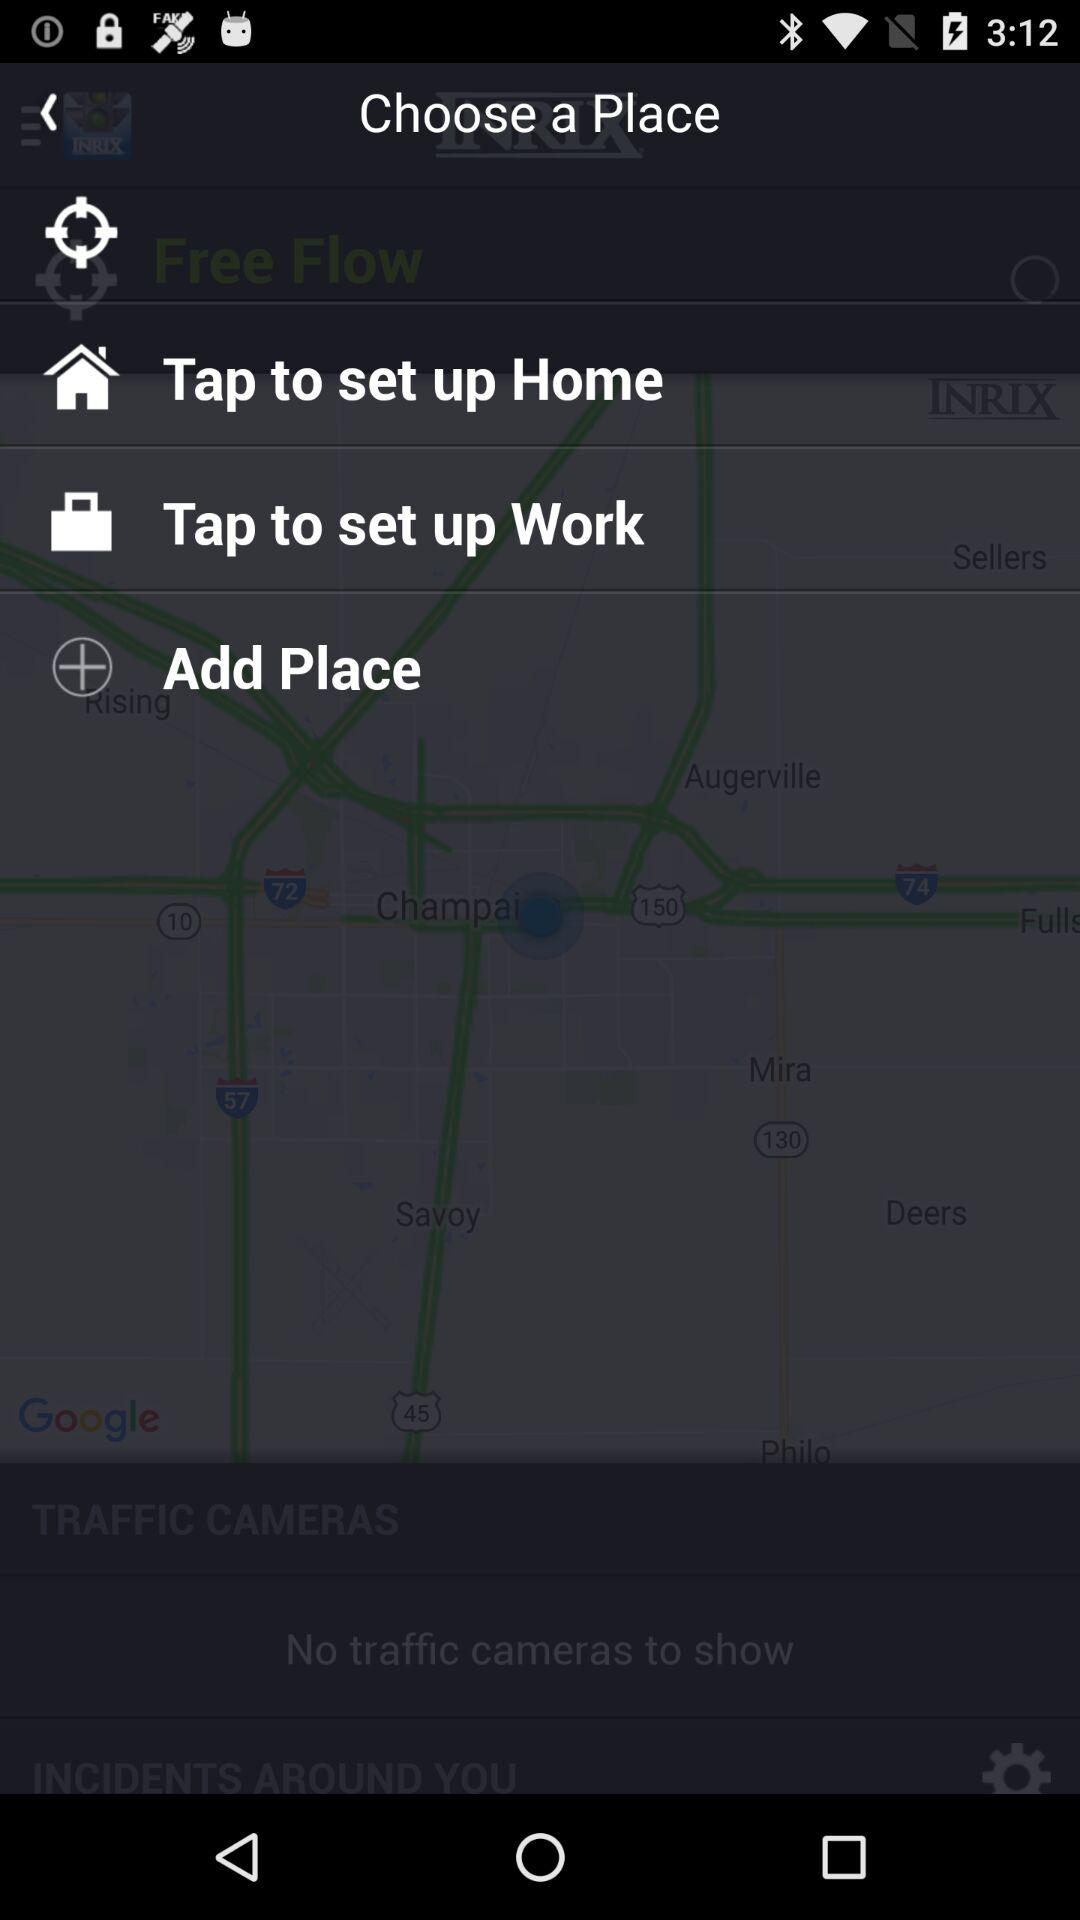How many options are available to choose a place?
Answer the question using a single word or phrase. 4 